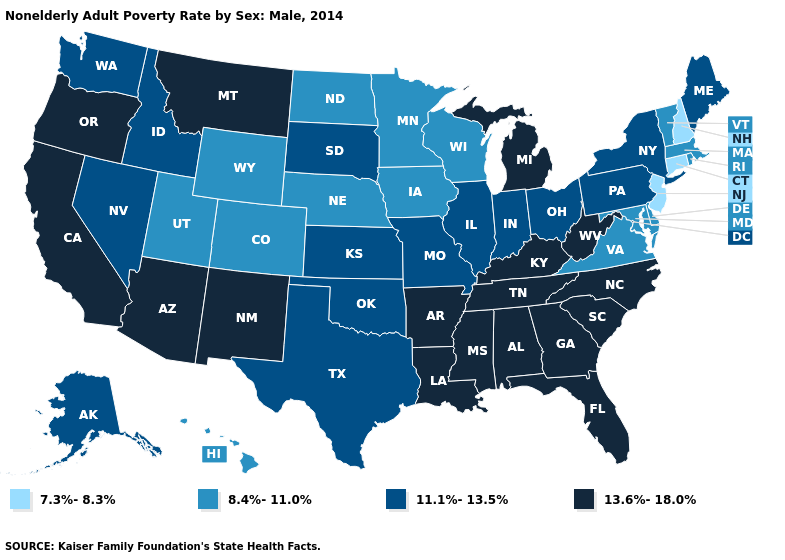Name the states that have a value in the range 7.3%-8.3%?
Write a very short answer. Connecticut, New Hampshire, New Jersey. Which states hav the highest value in the West?
Quick response, please. Arizona, California, Montana, New Mexico, Oregon. Does South Dakota have a lower value than Ohio?
Write a very short answer. No. What is the value of Texas?
Short answer required. 11.1%-13.5%. What is the value of Alaska?
Short answer required. 11.1%-13.5%. What is the highest value in the Northeast ?
Quick response, please. 11.1%-13.5%. What is the value of Wyoming?
Concise answer only. 8.4%-11.0%. What is the value of Vermont?
Keep it brief. 8.4%-11.0%. What is the value of Delaware?
Keep it brief. 8.4%-11.0%. Among the states that border Washington , which have the lowest value?
Answer briefly. Idaho. Does Tennessee have the highest value in the USA?
Write a very short answer. Yes. Name the states that have a value in the range 11.1%-13.5%?
Answer briefly. Alaska, Idaho, Illinois, Indiana, Kansas, Maine, Missouri, Nevada, New York, Ohio, Oklahoma, Pennsylvania, South Dakota, Texas, Washington. Name the states that have a value in the range 11.1%-13.5%?
Answer briefly. Alaska, Idaho, Illinois, Indiana, Kansas, Maine, Missouri, Nevada, New York, Ohio, Oklahoma, Pennsylvania, South Dakota, Texas, Washington. What is the value of Montana?
Answer briefly. 13.6%-18.0%. Does Arkansas have the highest value in the USA?
Short answer required. Yes. 